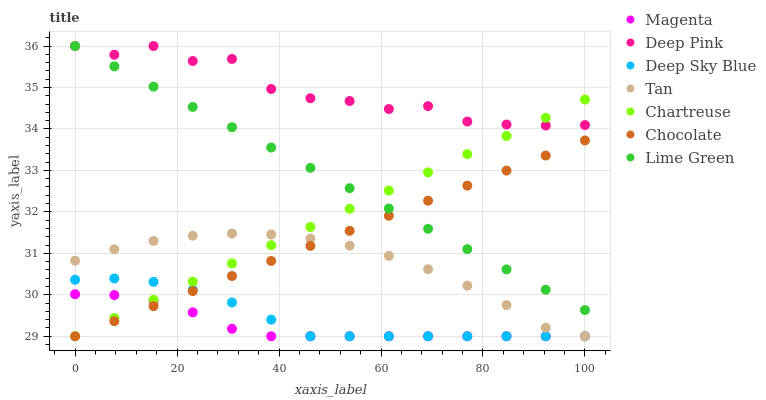Does Magenta have the minimum area under the curve?
Answer yes or no. Yes. Does Deep Pink have the maximum area under the curve?
Answer yes or no. Yes. Does Chocolate have the minimum area under the curve?
Answer yes or no. No. Does Chocolate have the maximum area under the curve?
Answer yes or no. No. Is Chocolate the smoothest?
Answer yes or no. Yes. Is Deep Pink the roughest?
Answer yes or no. Yes. Is Chartreuse the smoothest?
Answer yes or no. No. Is Chartreuse the roughest?
Answer yes or no. No. Does Chocolate have the lowest value?
Answer yes or no. Yes. Does Lime Green have the lowest value?
Answer yes or no. No. Does Lime Green have the highest value?
Answer yes or no. Yes. Does Chocolate have the highest value?
Answer yes or no. No. Is Magenta less than Lime Green?
Answer yes or no. Yes. Is Lime Green greater than Magenta?
Answer yes or no. Yes. Does Deep Sky Blue intersect Magenta?
Answer yes or no. Yes. Is Deep Sky Blue less than Magenta?
Answer yes or no. No. Is Deep Sky Blue greater than Magenta?
Answer yes or no. No. Does Magenta intersect Lime Green?
Answer yes or no. No. 